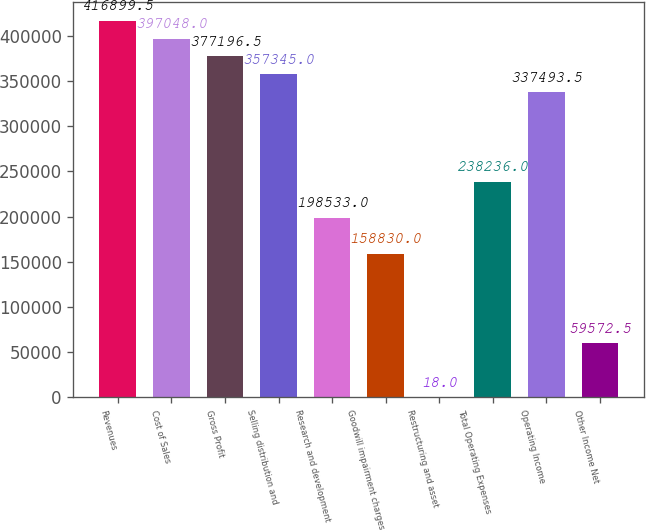Convert chart. <chart><loc_0><loc_0><loc_500><loc_500><bar_chart><fcel>Revenues<fcel>Cost of Sales<fcel>Gross Profit<fcel>Selling distribution and<fcel>Research and development<fcel>Goodwill impairment charges<fcel>Restructuring and asset<fcel>Total Operating Expenses<fcel>Operating Income<fcel>Other Income Net<nl><fcel>416900<fcel>397048<fcel>377196<fcel>357345<fcel>198533<fcel>158830<fcel>18<fcel>238236<fcel>337494<fcel>59572.5<nl></chart> 